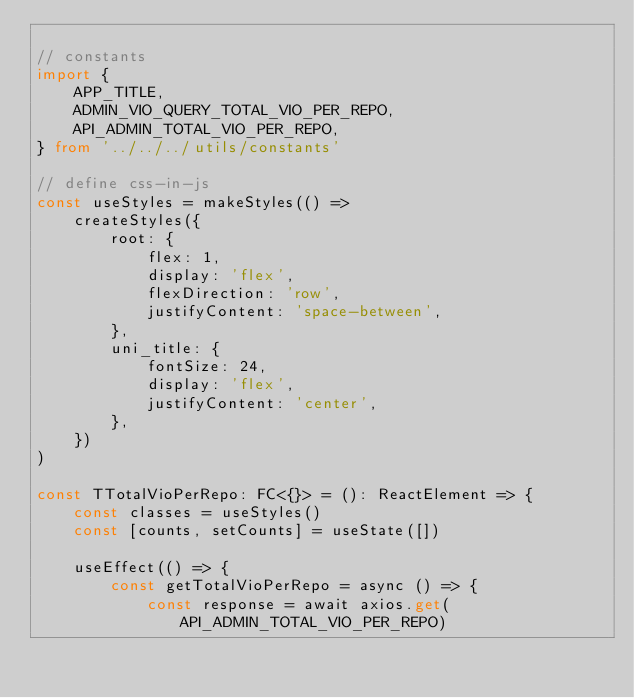<code> <loc_0><loc_0><loc_500><loc_500><_TypeScript_>
// constants
import {
    APP_TITLE,
    ADMIN_VIO_QUERY_TOTAL_VIO_PER_REPO,
    API_ADMIN_TOTAL_VIO_PER_REPO,
} from '../../../utils/constants'

// define css-in-js
const useStyles = makeStyles(() =>
    createStyles({
        root: {
            flex: 1,
            display: 'flex',
            flexDirection: 'row',
            justifyContent: 'space-between',
        },
        uni_title: {
            fontSize: 24,
            display: 'flex',
            justifyContent: 'center',
        },
    })
)

const TTotalVioPerRepo: FC<{}> = (): ReactElement => {
    const classes = useStyles()
    const [counts, setCounts] = useState([])

    useEffect(() => {
        const getTotalVioPerRepo = async () => {
            const response = await axios.get(API_ADMIN_TOTAL_VIO_PER_REPO)</code> 